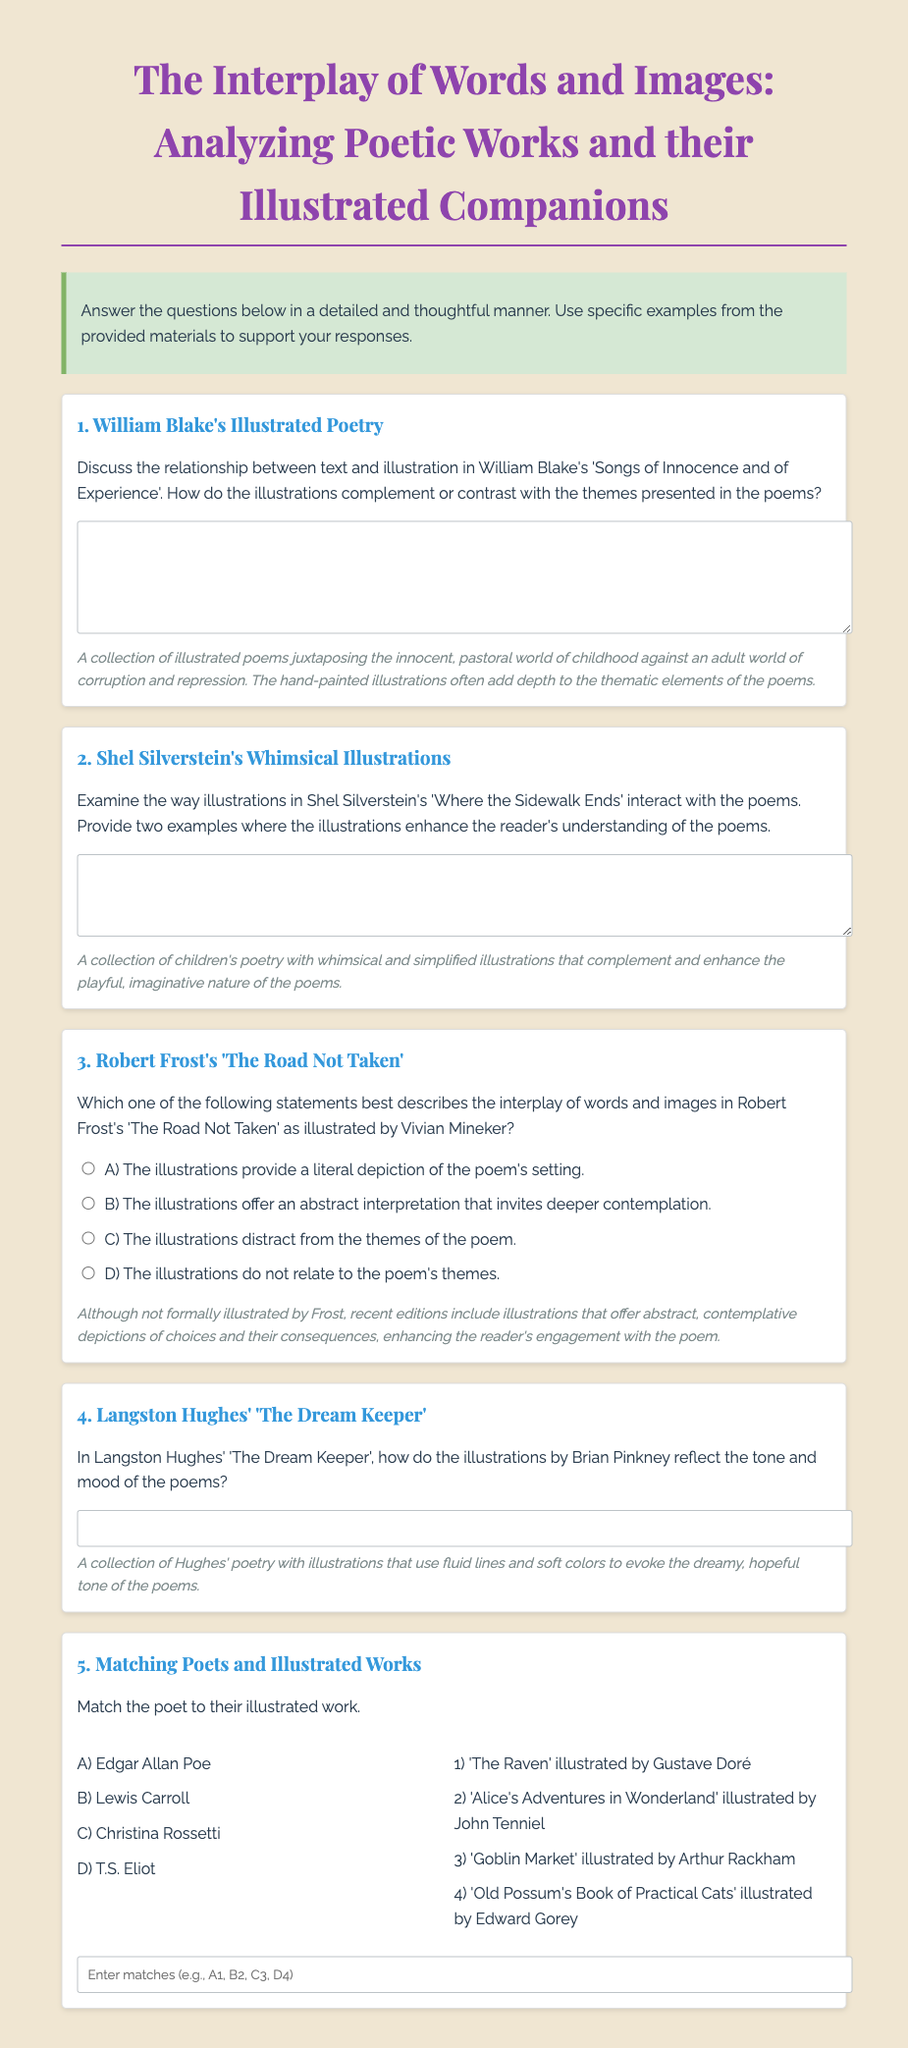What is the title of the midterm exam? The title is presented prominently at the top of the document and is "The Interplay of Words and Images: Analyzing Poetic Works and their Illustrated Companions."
Answer: The Interplay of Words and Images: Analyzing Poetic Works and their Illustrated Companions Who illustrated Robert Frost's 'The Road Not Taken'? The document mentions Vivian Mineker as the illustrator for Robert Frost's poem.
Answer: Vivian Mineker Which poet's illustrations are described as whimsical? The section referring to Shel Silverstein specifies that his illustrations are whimsical.
Answer: Shel Silverstein What is the main theme contrasted in William Blake's illustrated poems? The main theme described in the document is the contrast between the innocent world of childhood and the adult world of corruption.
Answer: Innocent childhood vs. adult corruption What do the illustrations in Langston Hughes' 'The Dream Keeper' evoke? The illustrations in Hughes' collection evoke a dreamy, hopeful tone as described in the additional information section.
Answer: Dreamy, hopeful tone Match poet A with Illustrated Work 1 The question involves matching Edgar Allan Poe with 'The Raven' illustrated by Gustave Doré, as specified in the matching section.
Answer: A1 